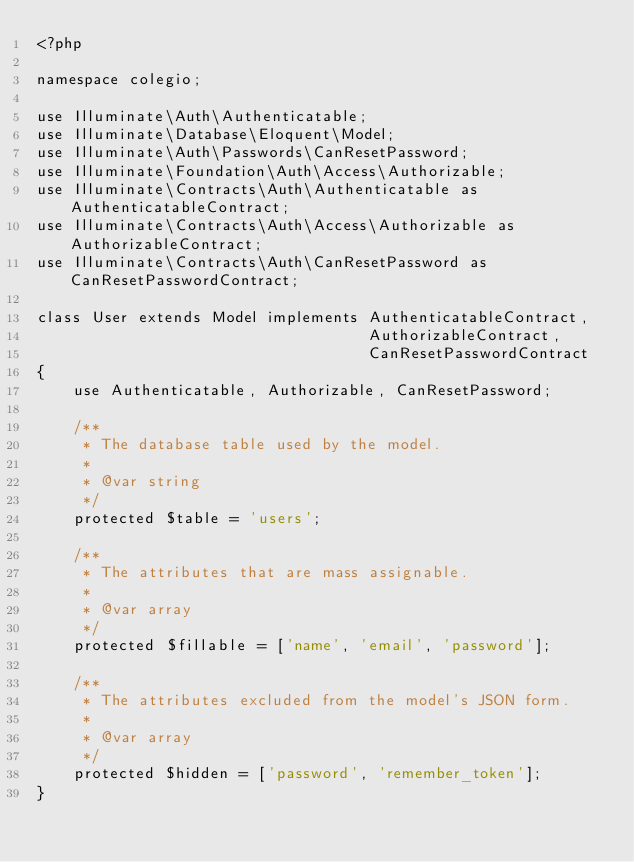<code> <loc_0><loc_0><loc_500><loc_500><_PHP_><?php

namespace colegio;

use Illuminate\Auth\Authenticatable;
use Illuminate\Database\Eloquent\Model;
use Illuminate\Auth\Passwords\CanResetPassword;
use Illuminate\Foundation\Auth\Access\Authorizable;
use Illuminate\Contracts\Auth\Authenticatable as AuthenticatableContract;
use Illuminate\Contracts\Auth\Access\Authorizable as AuthorizableContract;
use Illuminate\Contracts\Auth\CanResetPassword as CanResetPasswordContract;

class User extends Model implements AuthenticatableContract,
                                    AuthorizableContract,
                                    CanResetPasswordContract
{
    use Authenticatable, Authorizable, CanResetPassword;

    /**
     * The database table used by the model.
     *
     * @var string
     */
    protected $table = 'users';

    /**
     * The attributes that are mass assignable.
     *
     * @var array
     */
    protected $fillable = ['name', 'email', 'password'];

    /**
     * The attributes excluded from the model's JSON form.
     *
     * @var array
     */
    protected $hidden = ['password', 'remember_token'];
}
</code> 